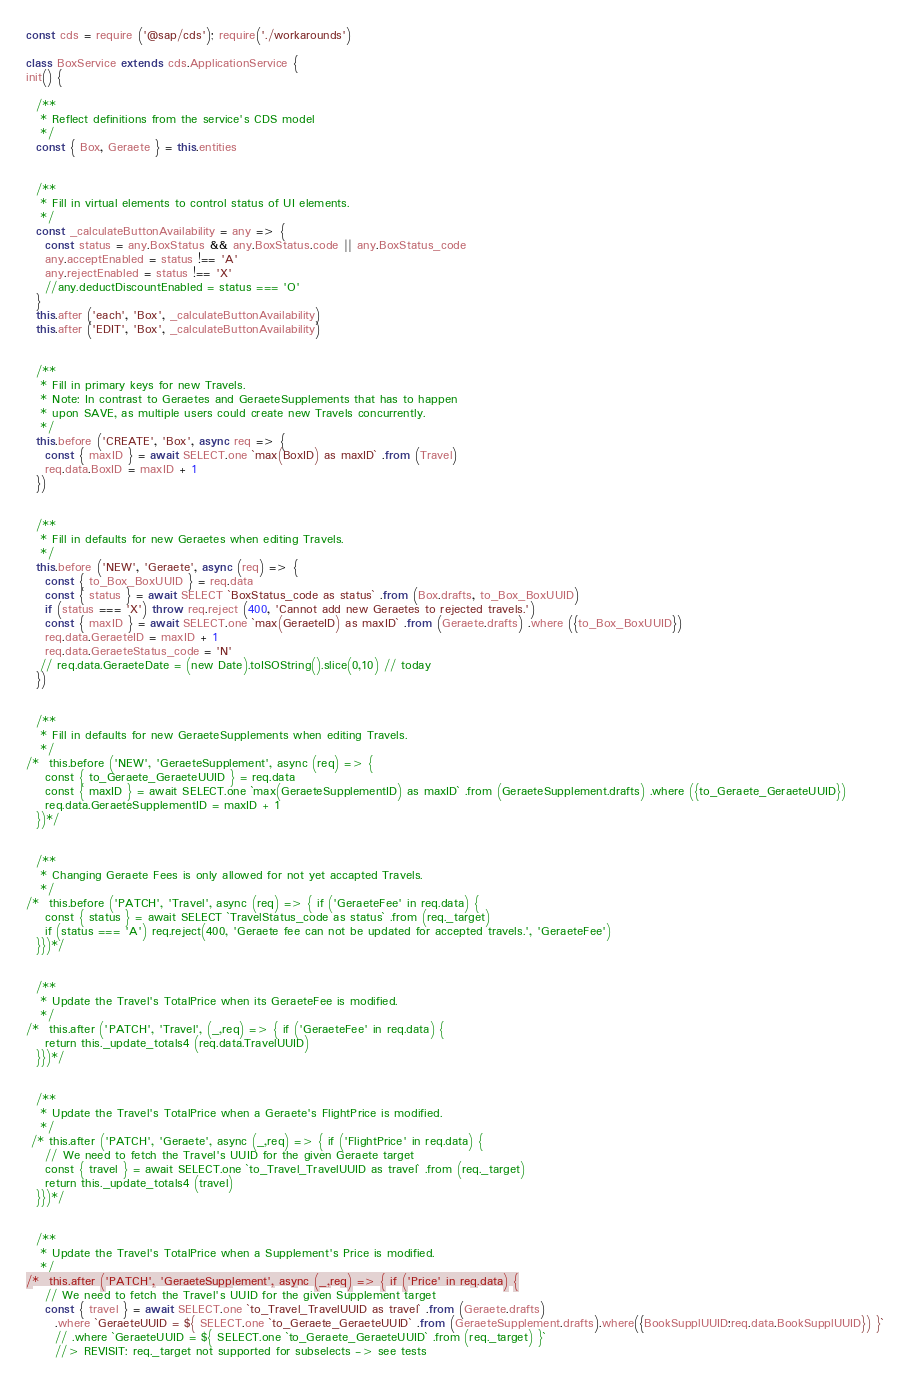<code> <loc_0><loc_0><loc_500><loc_500><_JavaScript_>const cds = require ('@sap/cds'); require('./workarounds')

class BoxService extends cds.ApplicationService {
init() {

  /**
   * Reflect definitions from the service's CDS model
   */
  const { Box, Geraete } = this.entities


  /**
   * Fill in virtual elements to control status of UI elements.
   */
  const _calculateButtonAvailability = any => {
    const status = any.BoxStatus && any.BoxStatus.code || any.BoxStatus_code
    any.acceptEnabled = status !== 'A'
    any.rejectEnabled = status !== 'X'
    //any.deductDiscountEnabled = status === 'O'
  }
  this.after ('each', 'Box', _calculateButtonAvailability)
  this.after ('EDIT', 'Box', _calculateButtonAvailability)


  /**
   * Fill in primary keys for new Travels.
   * Note: In contrast to Geraetes and GeraeteSupplements that has to happen
   * upon SAVE, as multiple users could create new Travels concurrently.
   */
  this.before ('CREATE', 'Box', async req => {
    const { maxID } = await SELECT.one `max(BoxID) as maxID` .from (Travel)
    req.data.BoxID = maxID + 1
  })


  /**
   * Fill in defaults for new Geraetes when editing Travels.
   */
  this.before ('NEW', 'Geraete', async (req) => {
    const { to_Box_BoxUUID } = req.data
    const { status } = await SELECT `BoxStatus_code as status` .from (Box.drafts, to_Box_BoxUUID)
    if (status === 'X') throw req.reject (400, 'Cannot add new Geraetes to rejected travels.')
    const { maxID } = await SELECT.one `max(GeraeteID) as maxID` .from (Geraete.drafts) .where ({to_Box_BoxUUID})
    req.data.GeraeteID = maxID + 1
    req.data.GeraeteStatus_code = 'N'
   // req.data.GeraeteDate = (new Date).toISOString().slice(0,10) // today
  })


  /**
   * Fill in defaults for new GeraeteSupplements when editing Travels.
   */
/*  this.before ('NEW', 'GeraeteSupplement', async (req) => {
    const { to_Geraete_GeraeteUUID } = req.data
    const { maxID } = await SELECT.one `max(GeraeteSupplementID) as maxID` .from (GeraeteSupplement.drafts) .where ({to_Geraete_GeraeteUUID})
    req.data.GeraeteSupplementID = maxID + 1
  })*/


  /**
   * Changing Geraete Fees is only allowed for not yet accapted Travels.
   */
/*  this.before ('PATCH', 'Travel', async (req) => { if ('GeraeteFee' in req.data) {
    const { status } = await SELECT `TravelStatus_code as status` .from (req._target)
    if (status === 'A') req.reject(400, 'Geraete fee can not be updated for accepted travels.', 'GeraeteFee')
  }})*/


  /**
   * Update the Travel's TotalPrice when its GeraeteFee is modified.
   */
/*  this.after ('PATCH', 'Travel', (_,req) => { if ('GeraeteFee' in req.data) {
    return this._update_totals4 (req.data.TravelUUID)
  }})*/


  /**
   * Update the Travel's TotalPrice when a Geraete's FlightPrice is modified.
   */
 /* this.after ('PATCH', 'Geraete', async (_,req) => { if ('FlightPrice' in req.data) {
    // We need to fetch the Travel's UUID for the given Geraete target
    const { travel } = await SELECT.one `to_Travel_TravelUUID as travel` .from (req._target)
    return this._update_totals4 (travel)
  }})*/


  /**
   * Update the Travel's TotalPrice when a Supplement's Price is modified.
   */
/*  this.after ('PATCH', 'GeraeteSupplement', async (_,req) => { if ('Price' in req.data) {
    // We need to fetch the Travel's UUID for the given Supplement target
    const { travel } = await SELECT.one `to_Travel_TravelUUID as travel` .from (Geraete.drafts)
      .where `GeraeteUUID = ${ SELECT.one `to_Geraete_GeraeteUUID` .from (GeraeteSupplement.drafts).where({BookSupplUUID:req.data.BookSupplUUID}) }`
      // .where `GeraeteUUID = ${ SELECT.one `to_Geraete_GeraeteUUID` .from (req._target) }`
      //> REVISIT: req._target not supported for subselects -> see tests</code> 